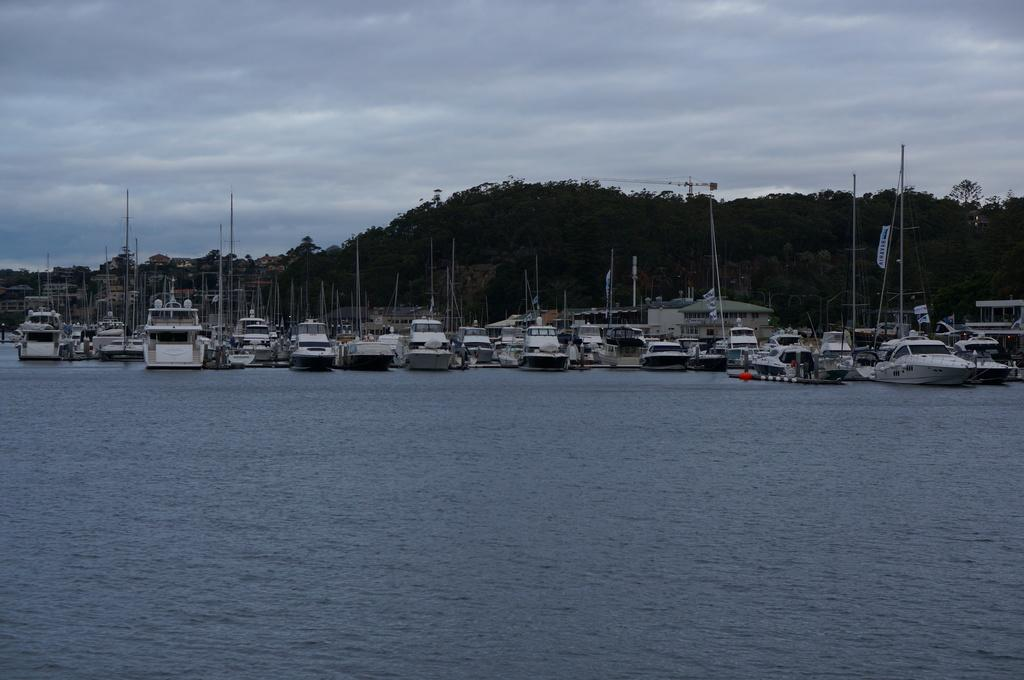What is located at the bottom of the image? There is a sea at the bottom of the image. What can be seen in the sea? There are boats in the sea. What type of vegetation is in the background of the image? There are trees in the background of the image. What is visible at the top of the image? The sky is visible at the top of the image. Where is the cake located in the image? There is no cake present in the image. What type of tent can be seen in the background of the image? There is no tent present in the image. 